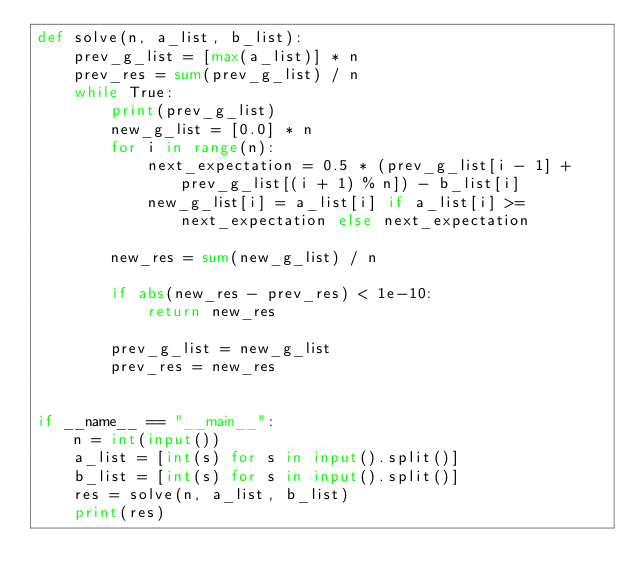Convert code to text. <code><loc_0><loc_0><loc_500><loc_500><_Python_>def solve(n, a_list, b_list):
    prev_g_list = [max(a_list)] * n
    prev_res = sum(prev_g_list) / n
    while True:
        print(prev_g_list)
        new_g_list = [0.0] * n
        for i in range(n):
            next_expectation = 0.5 * (prev_g_list[i - 1] + prev_g_list[(i + 1) % n]) - b_list[i]
            new_g_list[i] = a_list[i] if a_list[i] >= next_expectation else next_expectation

        new_res = sum(new_g_list) / n

        if abs(new_res - prev_res) < 1e-10:
            return new_res

        prev_g_list = new_g_list
        prev_res = new_res


if __name__ == "__main__":
    n = int(input())
    a_list = [int(s) for s in input().split()]
    b_list = [int(s) for s in input().split()]
    res = solve(n, a_list, b_list)
    print(res)
</code> 